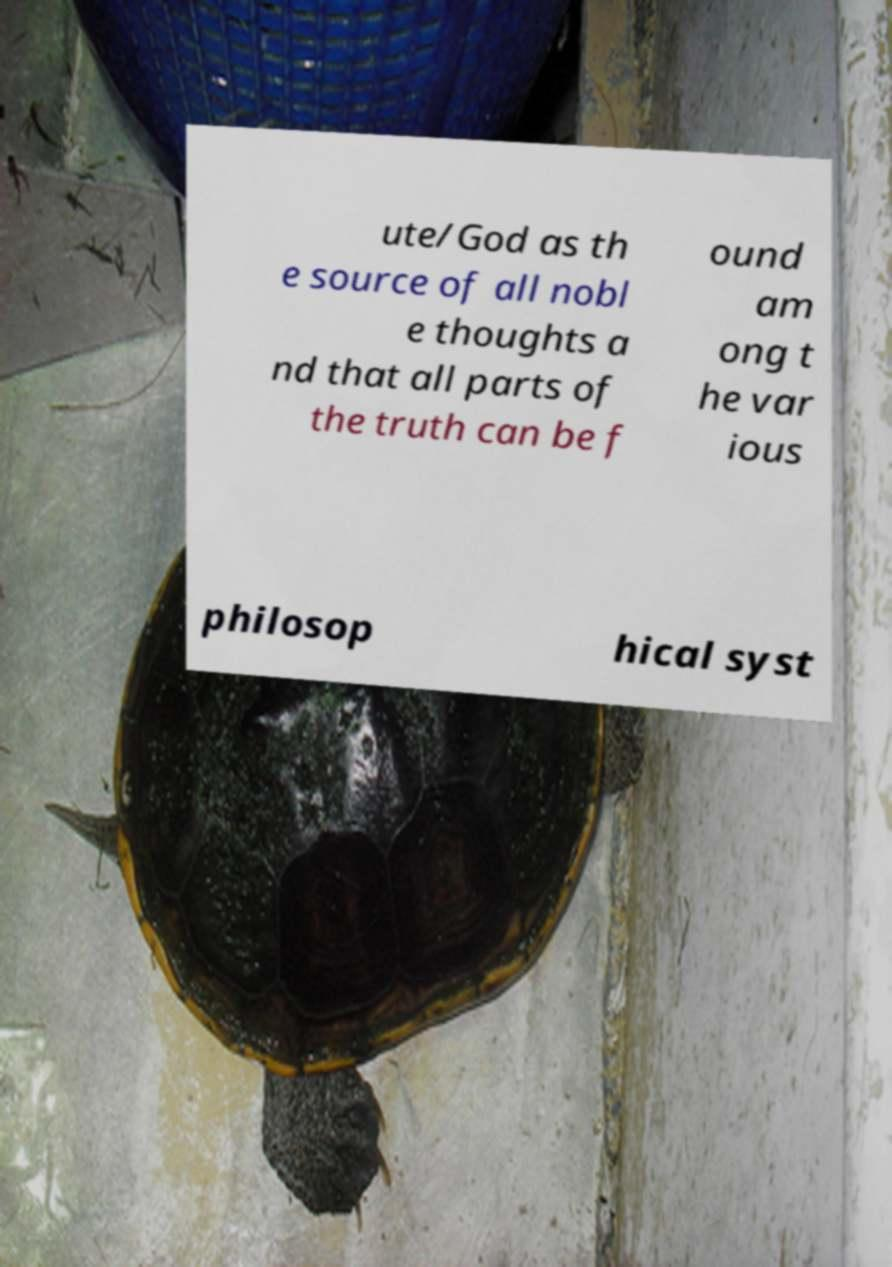For documentation purposes, I need the text within this image transcribed. Could you provide that? ute/God as th e source of all nobl e thoughts a nd that all parts of the truth can be f ound am ong t he var ious philosop hical syst 